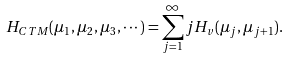Convert formula to latex. <formula><loc_0><loc_0><loc_500><loc_500>H _ { C T M } ( \mu _ { 1 } , \mu _ { 2 } , \mu _ { 3 } , \cdots ) = \sum _ { j = 1 } ^ { \infty } j H _ { v } ( \mu _ { j } , \mu _ { j + 1 } ) .</formula> 